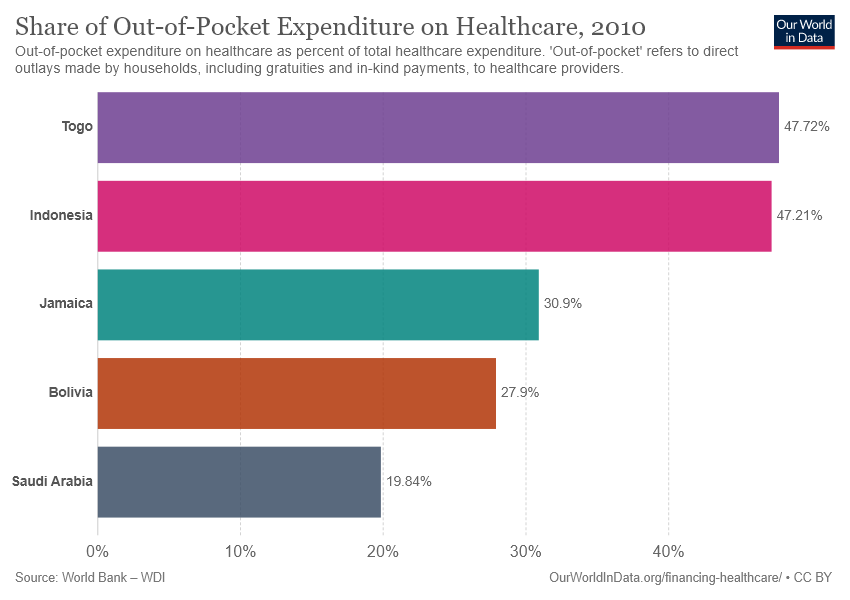Specify some key components in this picture. The value of pink bar is 47.21. 